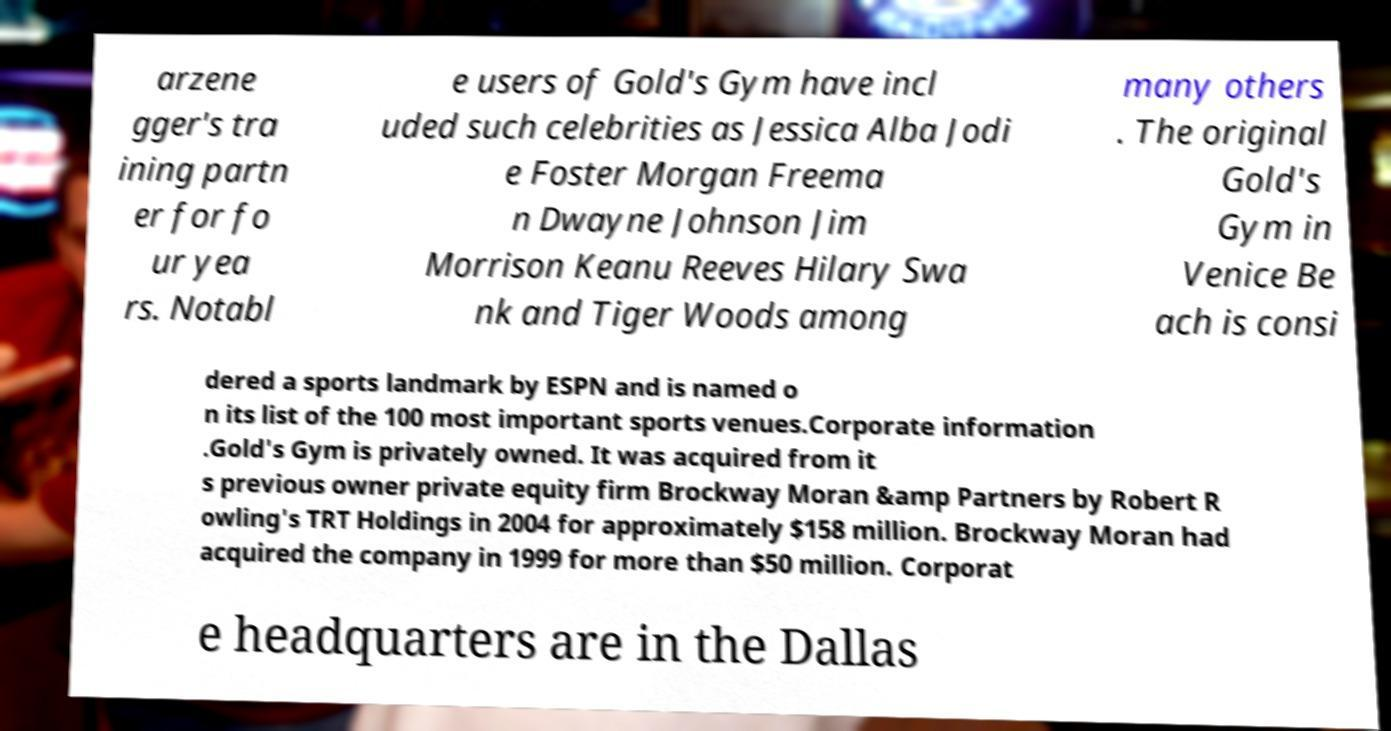What messages or text are displayed in this image? I need them in a readable, typed format. arzene gger's tra ining partn er for fo ur yea rs. Notabl e users of Gold's Gym have incl uded such celebrities as Jessica Alba Jodi e Foster Morgan Freema n Dwayne Johnson Jim Morrison Keanu Reeves Hilary Swa nk and Tiger Woods among many others . The original Gold's Gym in Venice Be ach is consi dered a sports landmark by ESPN and is named o n its list of the 100 most important sports venues.Corporate information .Gold's Gym is privately owned. It was acquired from it s previous owner private equity firm Brockway Moran &amp Partners by Robert R owling's TRT Holdings in 2004 for approximately $158 million. Brockway Moran had acquired the company in 1999 for more than $50 million. Corporat e headquarters are in the Dallas 